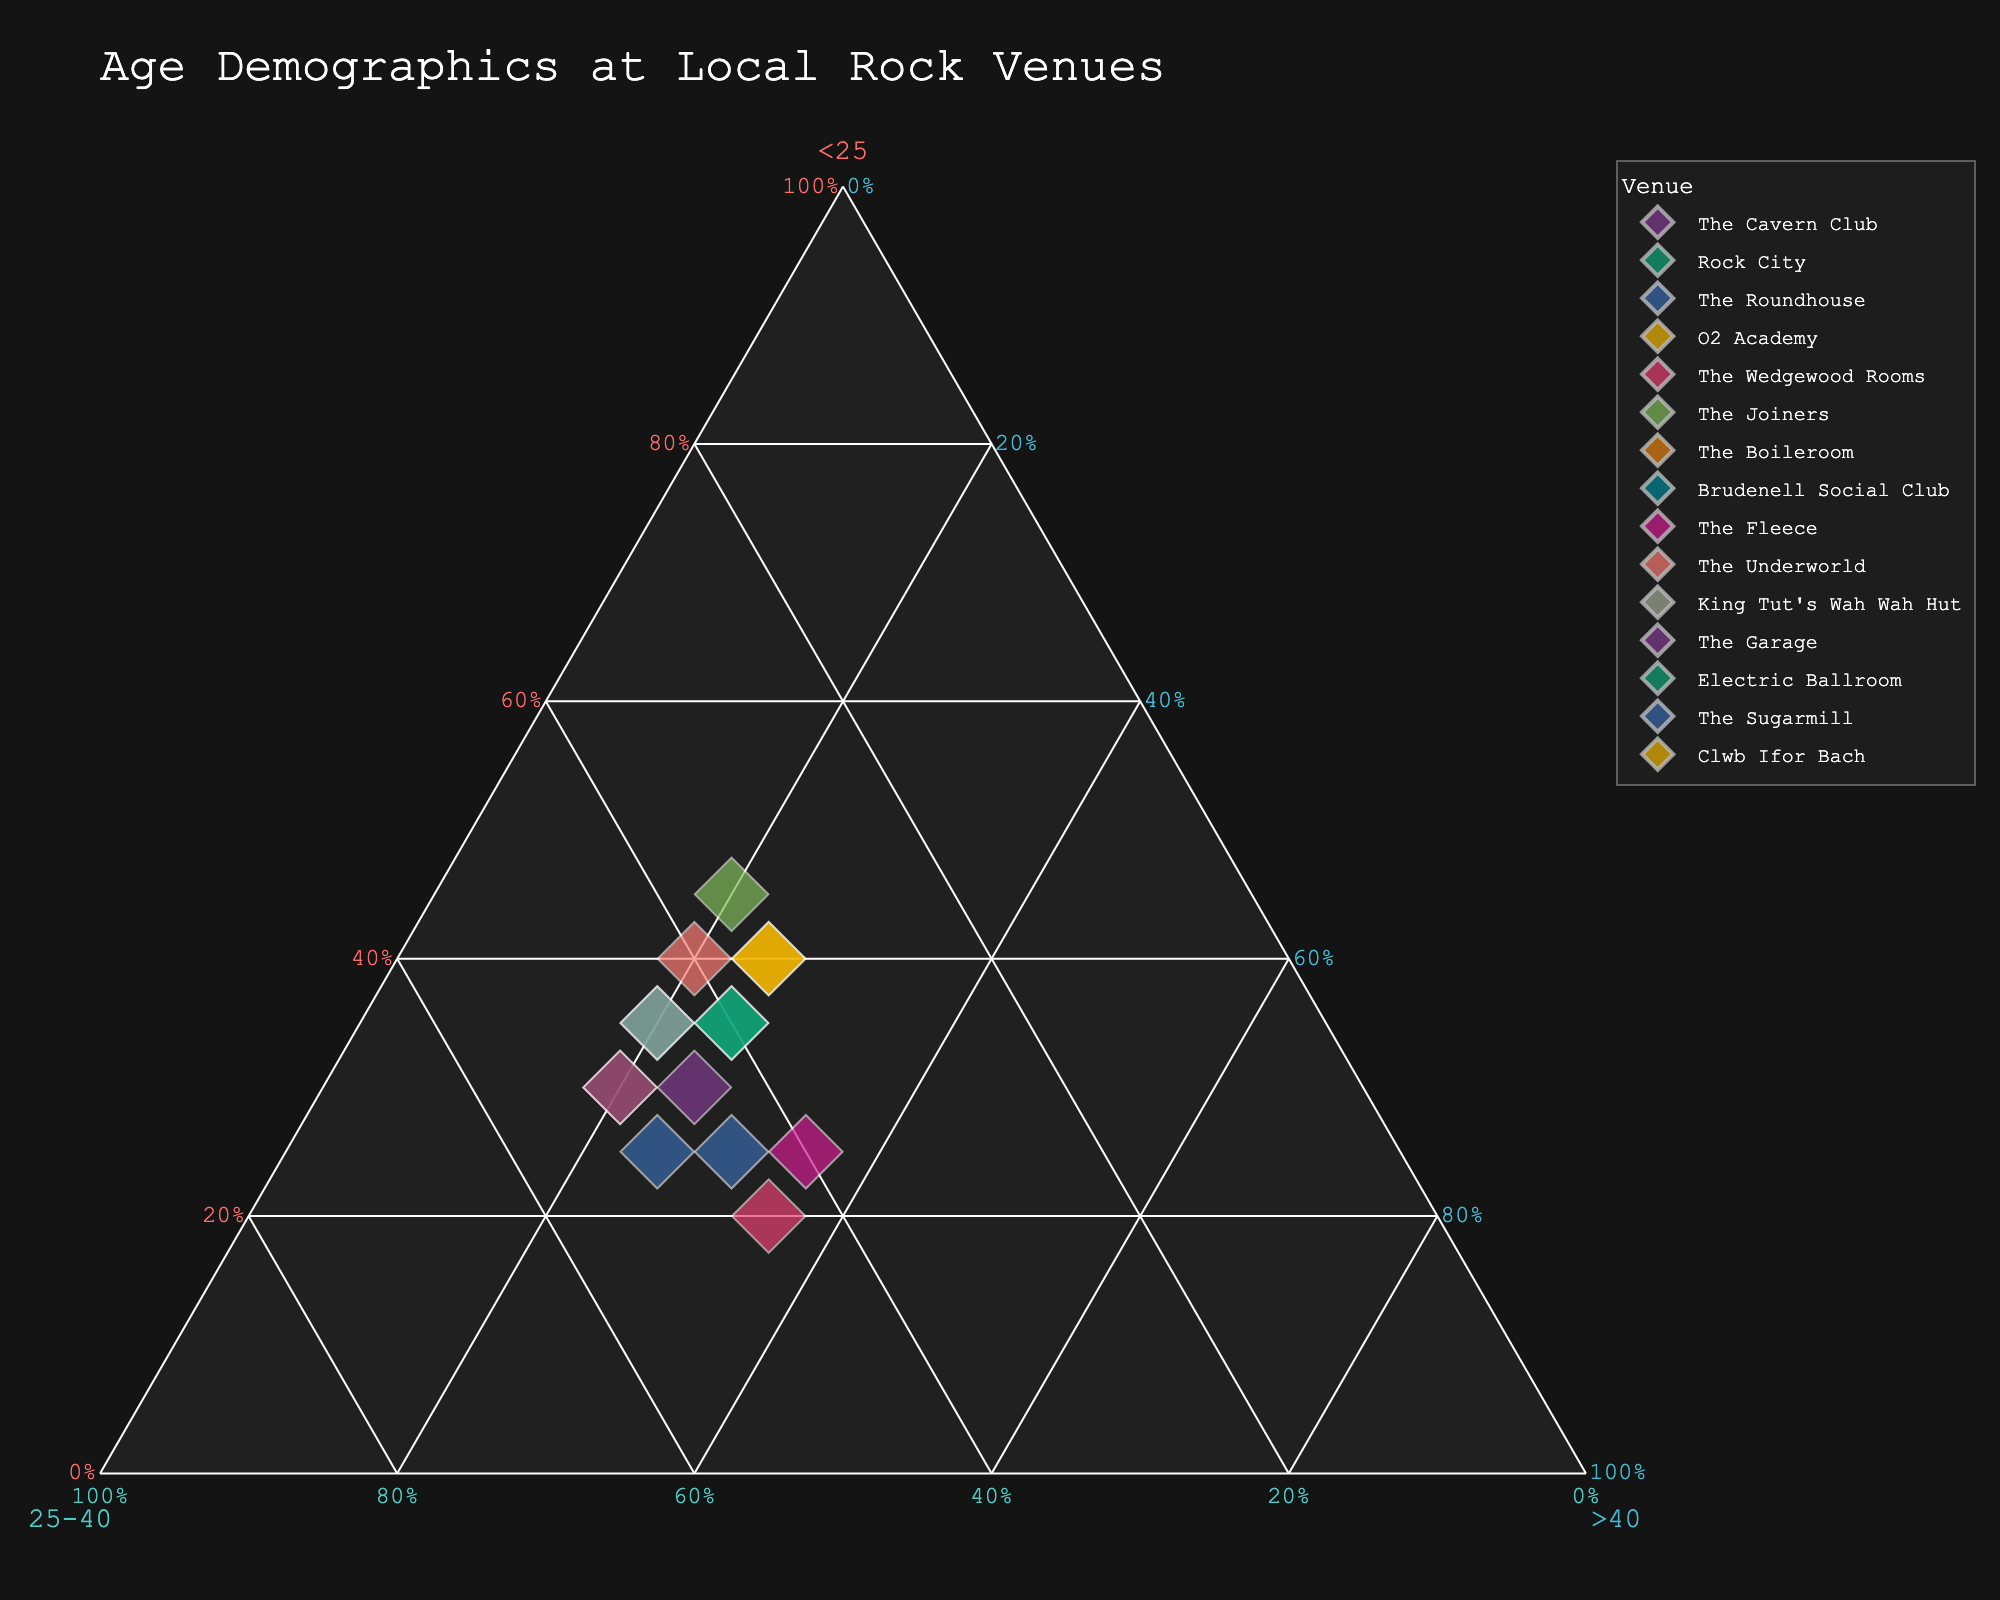What does the title of the figure indicate about the data? The title "Age Demographics at Local Rock Venues" indicates that the figure shows the age distribution of audiences at different rock music venues.
Answer: Age Demographics at Local Rock Venues How many venues are represented in the figure? Each point represents a venue, and there are 15 points, so there are 15 venues.
Answer: 15 Which age group tends to have the highest proportion across most venues? By examining the plot distribution, the age group 25-40 sees the highest proportions because most points are clustered towards the side labeled 25-40.
Answer: 25-40 What’s the proportion of under-25 audience at The Joiners? Locate The Joiners on the ternary plot, which is closer to the Under 25 axis, indicating a higher proportion. The data shows about 45%.
Answer: 45% Which venue has the most balanced audience age distribution? Points closer to the center indicate a balanced distribution. The Cavern Club and Electric Ballroom are near the center, suggesting a more balanced age spread.
Answer: The Cavern Club, Electric Ballroom Compare the age group proportions for The Garage and The Boileroom. How are they different? The Garage has more equal proportions between Under25 (30%) and 25-40 (50%), with Over40 (20%). The Boileroom has higher 25-40 (50%), equal Under25 (30%), and Over40 (20%) proportions.
Answer: The Garage: Under25 (30%), 25-40 (50%), Over40 (20%); The Boileroom: Under25 (30%), 25-40 (50%), Over40 (20%) Which venue has the highest proportion of the over-40 age group? Identify the point closest to the Over40 axis. The Fleece and The Wedgewood Rooms are close, with data showing about 35% for each.
Answer: The Fleece, The Wedgewood Rooms Which venue has the lowest under-25 audience proportion? Locate the point farthest from the Under25 axis. The Wedgewood Rooms (20%) have the lowest proportion.
Answer: The Wedgewood Rooms What’s the average proportion of the 25-40 age group across all venues? Sum the proportions for the 25-40 group (weighted by 45, 40, 50, 35, 45, 35, 50, 45, 40, 40, 45, 50, 40, 45, 35) and average: (35+40+50+35+45+40+50+45+40+40+45+50+40+45+35)/15 = 41.
Answer: 41% Locate which venue has the most under-25 and which has the most over-40 audience. The Joiners has the most under-25 (45%), and The Fleece and The Wedgewood Rooms both have the most over-40 (35%).
Answer: The Joiners (Under 25), The Fleece & The Wedgewood Rooms (Over 40) Have any venues shown equally distributed age groups among all three age groups? Check for points near the center. None are perfectly centered, but The Cavern Club (30% Under25, 45% 25-40, 25% Over40) is quite balanced.
Answer: None perfectly, but The Cavern Club is closest 